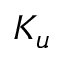Convert formula to latex. <formula><loc_0><loc_0><loc_500><loc_500>K _ { u }</formula> 